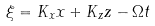Convert formula to latex. <formula><loc_0><loc_0><loc_500><loc_500>\xi = K _ { x } x + K _ { z } z - \Omega t</formula> 